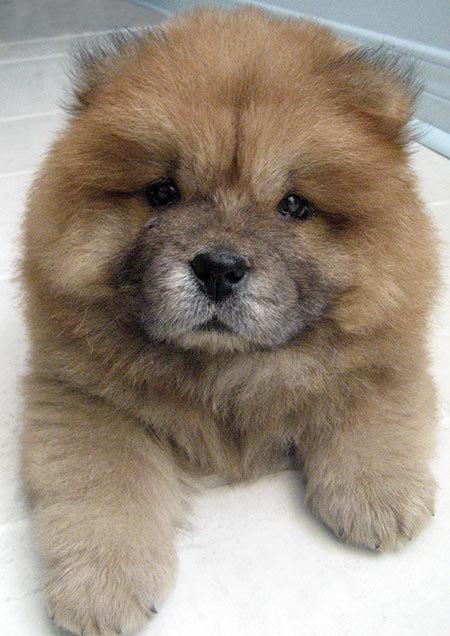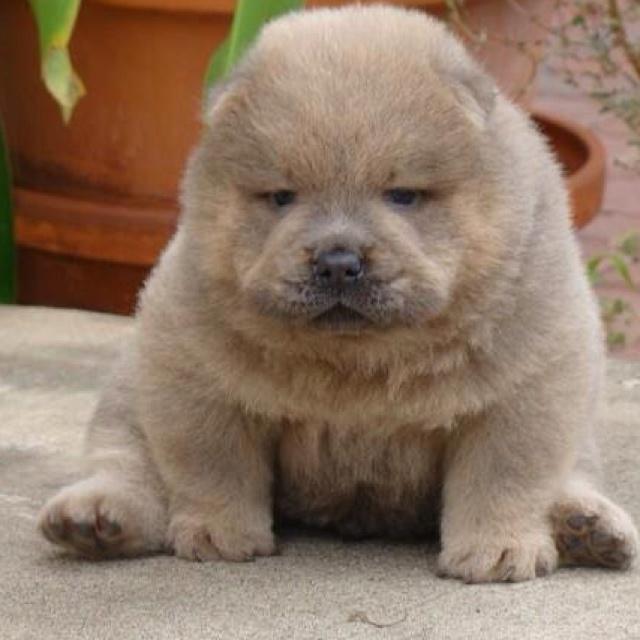The first image is the image on the left, the second image is the image on the right. Analyze the images presented: Is the assertion "The right image shows a chow eyeing the camera, with its head turned at a distinct angle." valid? Answer yes or no. No. 